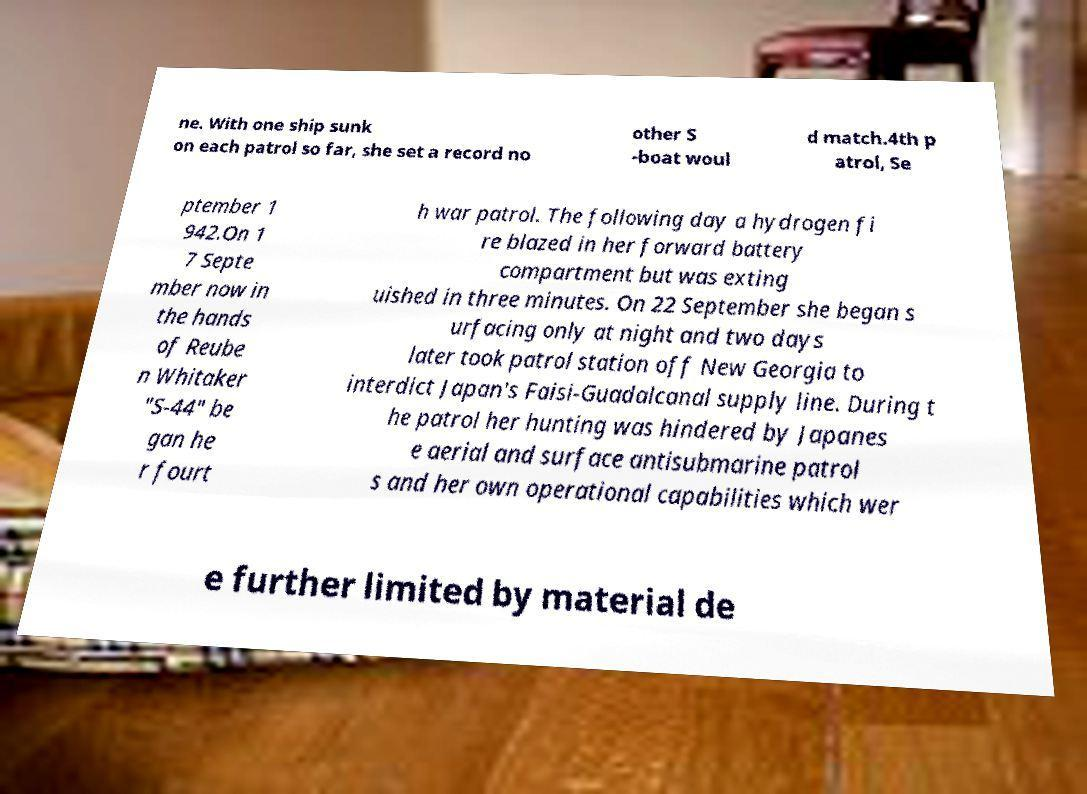Can you accurately transcribe the text from the provided image for me? ne. With one ship sunk on each patrol so far, she set a record no other S -boat woul d match.4th p atrol, Se ptember 1 942.On 1 7 Septe mber now in the hands of Reube n Whitaker "S-44" be gan he r fourt h war patrol. The following day a hydrogen fi re blazed in her forward battery compartment but was exting uished in three minutes. On 22 September she began s urfacing only at night and two days later took patrol station off New Georgia to interdict Japan's Faisi-Guadalcanal supply line. During t he patrol her hunting was hindered by Japanes e aerial and surface antisubmarine patrol s and her own operational capabilities which wer e further limited by material de 